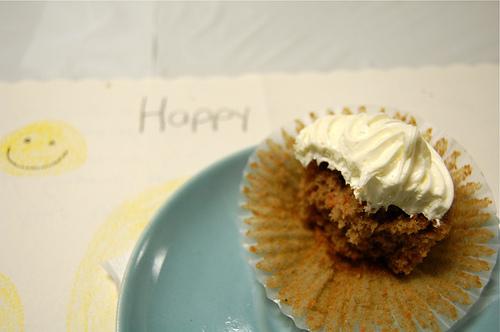What kind of cupcake is this?
Be succinct. Carrot. How many bytes are left in the cupcake?
Be succinct. 2. What is the word next to the sun?
Concise answer only. Happy. What is on top of the pastry?
Short answer required. Frosting. 